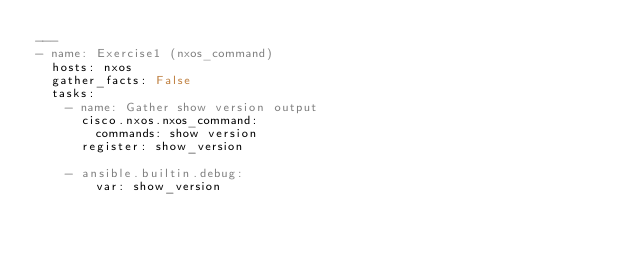Convert code to text. <code><loc_0><loc_0><loc_500><loc_500><_YAML_>---
- name: Exercise1 (nxos_command)
  hosts: nxos
  gather_facts: False
  tasks:
    - name: Gather show version output
      cisco.nxos.nxos_command:
        commands: show version
      register: show_version

    - ansible.builtin.debug:
        var: show_version
</code> 